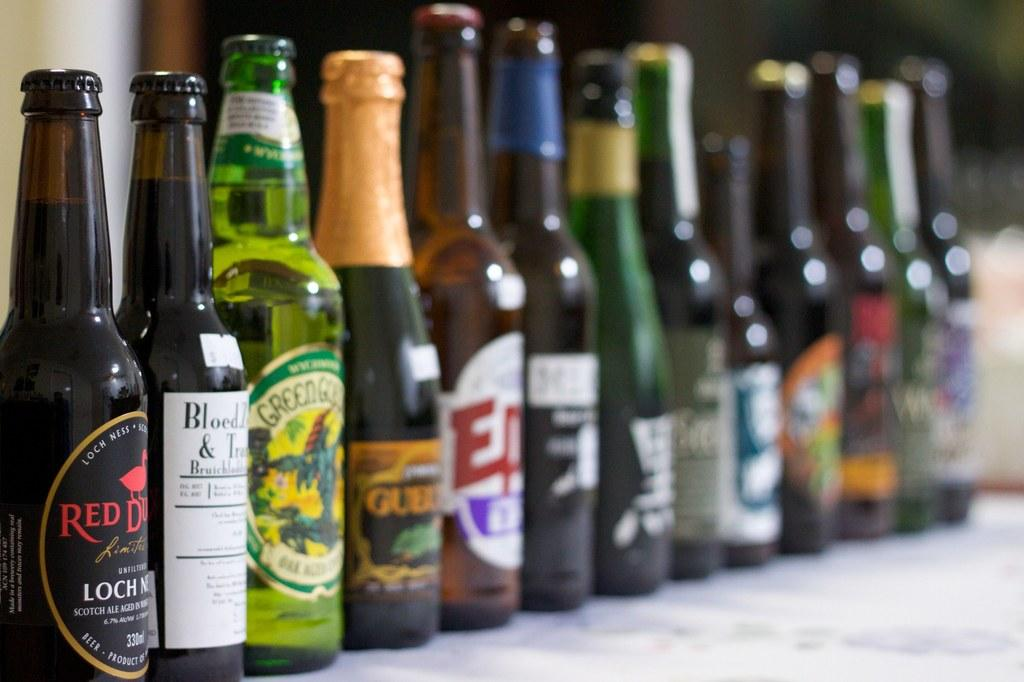<image>
Offer a succinct explanation of the picture presented. A bottle of Loch Ness beer is on the far left of a line of bottles. 